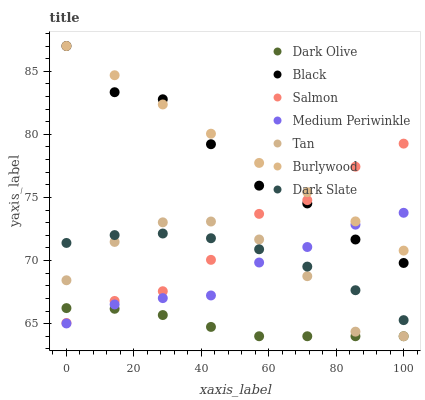Does Dark Olive have the minimum area under the curve?
Answer yes or no. Yes. Does Burlywood have the maximum area under the curve?
Answer yes or no. Yes. Does Medium Periwinkle have the minimum area under the curve?
Answer yes or no. No. Does Medium Periwinkle have the maximum area under the curve?
Answer yes or no. No. Is Burlywood the smoothest?
Answer yes or no. Yes. Is Tan the roughest?
Answer yes or no. Yes. Is Medium Periwinkle the smoothest?
Answer yes or no. No. Is Medium Periwinkle the roughest?
Answer yes or no. No. Does Dark Olive have the lowest value?
Answer yes or no. Yes. Does Medium Periwinkle have the lowest value?
Answer yes or no. No. Does Black have the highest value?
Answer yes or no. Yes. Does Medium Periwinkle have the highest value?
Answer yes or no. No. Is Dark Slate less than Burlywood?
Answer yes or no. Yes. Is Burlywood greater than Dark Slate?
Answer yes or no. Yes. Does Burlywood intersect Salmon?
Answer yes or no. Yes. Is Burlywood less than Salmon?
Answer yes or no. No. Is Burlywood greater than Salmon?
Answer yes or no. No. Does Dark Slate intersect Burlywood?
Answer yes or no. No. 